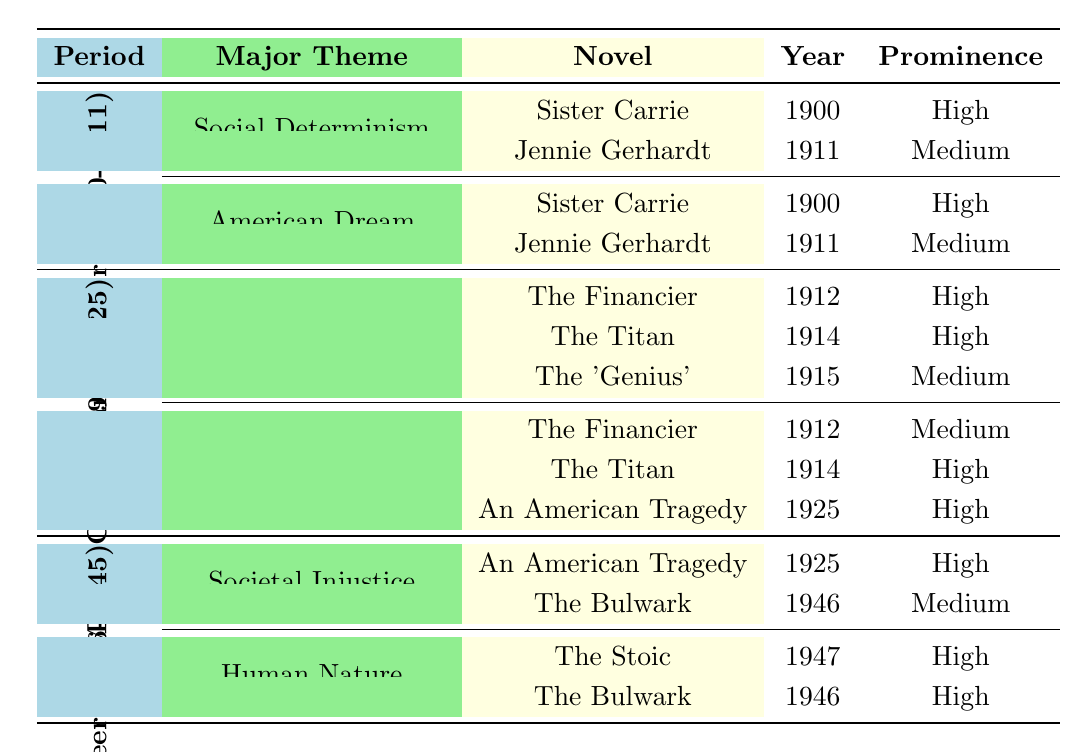What are the major themes in Dreiser's early career novels? There are two major themes identified in Dreiser's early career novels: Social Determinism and the American Dream. Both of these themes are explored in "Sister Carrie" and "Jennie Gerhardt."
Answer: Social Determinism and American Dream Which novel from Dreiser's middle career addresses both capitalism and moral ambiguity? "The Titan" appears in both the Capitalism and Greed theme and the Moral Ambiguity theme, indicating it addresses both aspects.
Answer: The Titan How many novels in total are associated with the theme of Societal Injustice during Dreiser's late career? "An American Tragedy" and "The Bulwark" are the two novels listed under Societal Injustice in the late career section, making a total of two novels.
Answer: 2 Which theme has the most high prominence novels in Dreiser's middle career? In the middle career, the theme "Capitalism and Greed" has three novels, out of which "The Financier" and "The Titan" are high, while "The 'Genius'" is medium. The theme "Moral Ambiguity" also has three novels, with "The Titan" and "An American Tragedy" being high. Both themes have the same number of high prominence novels.
Answer: Both themes have the same Is there any novel listed under both Social Determinism and American Dream? Yes, "Sister Carrie" appears under both themes in Dreiser's early career.
Answer: Yes What is the prominent theme in the late career that involves the nature of man? The theme that involves the nature of man in Dreiser's late career is "Human Nature," which is explored in two mentioned novels.
Answer: Human Nature Which period contains the highest number of novels focused on the theme of Capitalism and Greed? The middle career period has the most novels focused on Capitalism and Greed, with a total of three novels, indicating its significance during this time.
Answer: Middle Career How many times does the theme of Moral Ambiguity appear in the table, and which novels are associated with it? Moral Ambiguity appears twice under the middle career period, and the associated novels are "The Financier," "The Titan," and "An American Tragedy."
Answer: 2 times: The Financier, The Titan, and An American Tragedy In what ways did Dreiser's thematic focus shift between his early and late careers? Dreiser's early career focuses on individual struggles within societal frameworks (Social Determinism and American Dream), while his late career examines broader issues like Societal Injustice and Human Nature, reflecting a shift from individualism to social structural critiques.
Answer: From individual struggles to societal critiques Which novel marked the end of Dreiser's early career in 1911? "Jennie Gerhardt" is the novel that marked the end of Dreiser's early career in 1911.
Answer: Jennie Gerhardt 